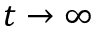Convert formula to latex. <formula><loc_0><loc_0><loc_500><loc_500>t \to \infty</formula> 